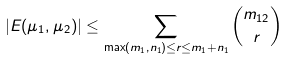Convert formula to latex. <formula><loc_0><loc_0><loc_500><loc_500>| E ( \mu _ { 1 } , \mu _ { 2 } ) | \leq \sum _ { \max ( m _ { 1 } , n _ { 1 } ) \leq r \leq m _ { 1 } + n _ { 1 } } \binom { m _ { 1 2 } } { r }</formula> 